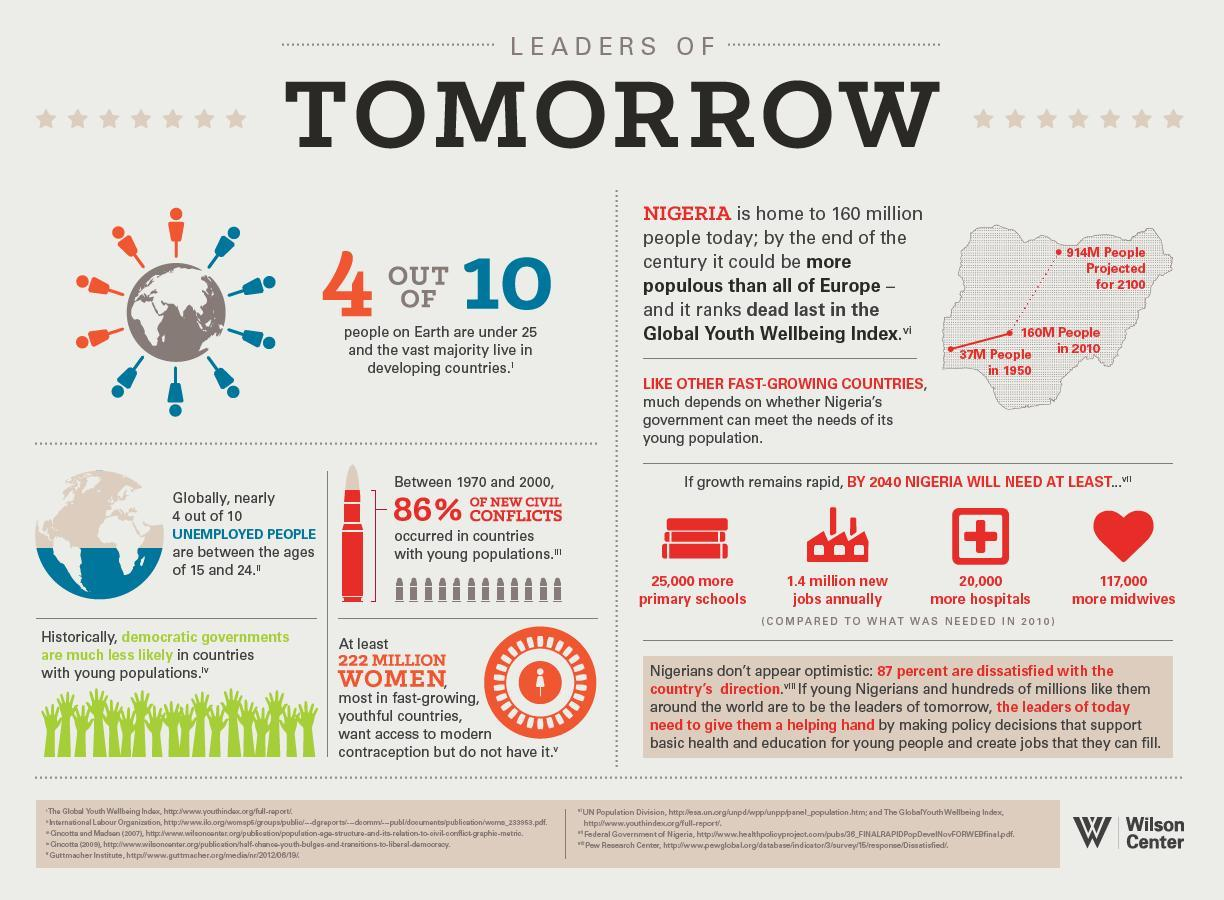Out of 10, how many unemployed people are not between the ages of 15 and 24?
Answer the question with a short phrase. 6 What percentage of new civil conflicts occurred not in countries with young people? 14% Out of 10, how many people on earth are not under 25, and the vast majority did not live in developing countries? 6 